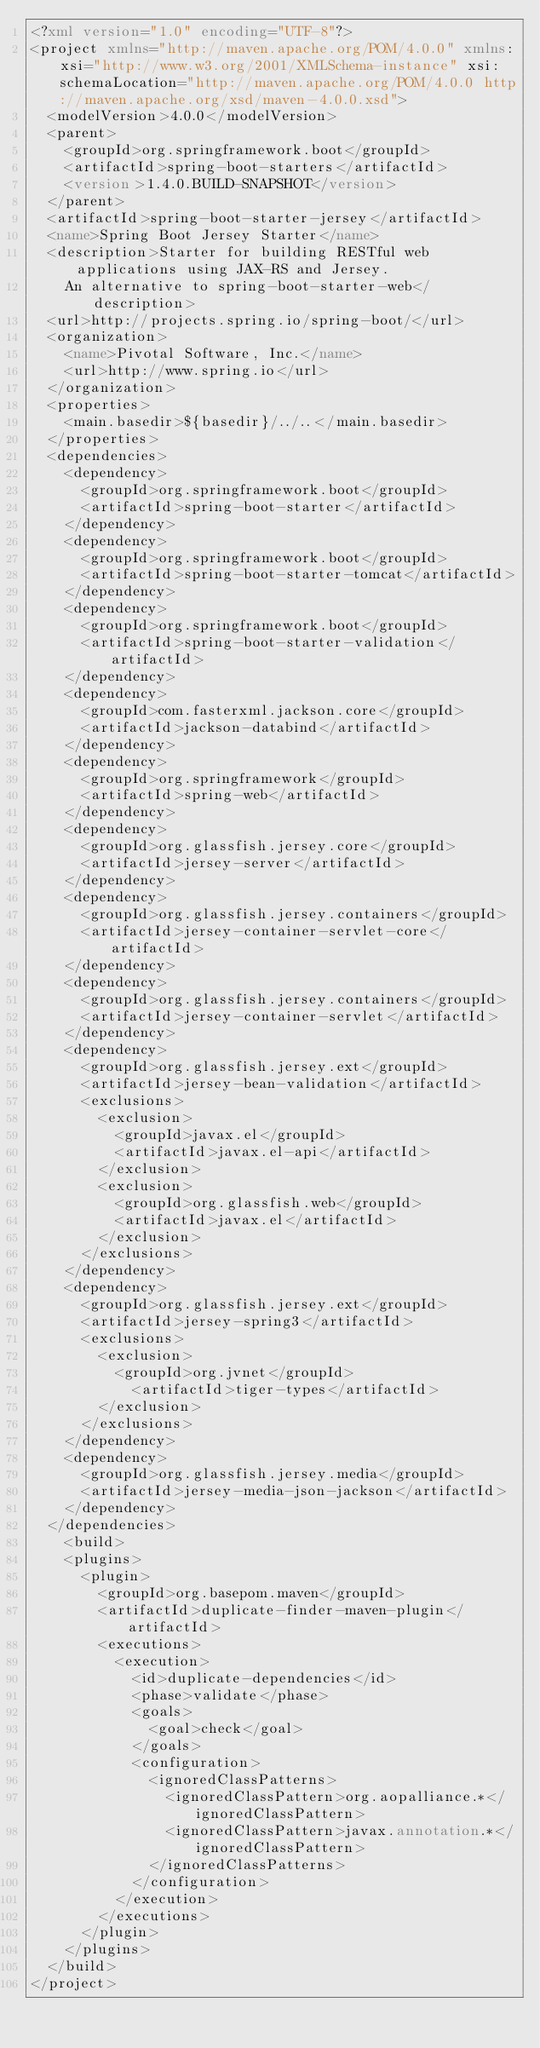<code> <loc_0><loc_0><loc_500><loc_500><_XML_><?xml version="1.0" encoding="UTF-8"?>
<project xmlns="http://maven.apache.org/POM/4.0.0" xmlns:xsi="http://www.w3.org/2001/XMLSchema-instance" xsi:schemaLocation="http://maven.apache.org/POM/4.0.0 http://maven.apache.org/xsd/maven-4.0.0.xsd">
	<modelVersion>4.0.0</modelVersion>
	<parent>
		<groupId>org.springframework.boot</groupId>
		<artifactId>spring-boot-starters</artifactId>
		<version>1.4.0.BUILD-SNAPSHOT</version>
	</parent>
	<artifactId>spring-boot-starter-jersey</artifactId>
	<name>Spring Boot Jersey Starter</name>
	<description>Starter for building RESTful web applications using JAX-RS and Jersey.
		An alternative to spring-boot-starter-web</description>
	<url>http://projects.spring.io/spring-boot/</url>
	<organization>
		<name>Pivotal Software, Inc.</name>
		<url>http://www.spring.io</url>
	</organization>
	<properties>
		<main.basedir>${basedir}/../..</main.basedir>
	</properties>
	<dependencies>
		<dependency>
			<groupId>org.springframework.boot</groupId>
			<artifactId>spring-boot-starter</artifactId>
		</dependency>
		<dependency>
			<groupId>org.springframework.boot</groupId>
			<artifactId>spring-boot-starter-tomcat</artifactId>
		</dependency>
		<dependency>
			<groupId>org.springframework.boot</groupId>
			<artifactId>spring-boot-starter-validation</artifactId>
		</dependency>
		<dependency>
			<groupId>com.fasterxml.jackson.core</groupId>
			<artifactId>jackson-databind</artifactId>
		</dependency>
		<dependency>
			<groupId>org.springframework</groupId>
			<artifactId>spring-web</artifactId>
		</dependency>
		<dependency>
			<groupId>org.glassfish.jersey.core</groupId>
			<artifactId>jersey-server</artifactId>
		</dependency>
		<dependency>
			<groupId>org.glassfish.jersey.containers</groupId>
			<artifactId>jersey-container-servlet-core</artifactId>
		</dependency>
		<dependency>
			<groupId>org.glassfish.jersey.containers</groupId>
			<artifactId>jersey-container-servlet</artifactId>
		</dependency>
		<dependency>
			<groupId>org.glassfish.jersey.ext</groupId>
			<artifactId>jersey-bean-validation</artifactId>
			<exclusions>
				<exclusion>
					<groupId>javax.el</groupId>
					<artifactId>javax.el-api</artifactId>
				</exclusion>
				<exclusion>
					<groupId>org.glassfish.web</groupId>
					<artifactId>javax.el</artifactId>
				</exclusion>
			</exclusions>
		</dependency>
		<dependency>
			<groupId>org.glassfish.jersey.ext</groupId>
			<artifactId>jersey-spring3</artifactId>
			<exclusions>
				<exclusion>
					<groupId>org.jvnet</groupId>
  					<artifactId>tiger-types</artifactId>
				</exclusion>
			</exclusions>
		</dependency>
		<dependency>
			<groupId>org.glassfish.jersey.media</groupId>
			<artifactId>jersey-media-json-jackson</artifactId>
		</dependency>
	</dependencies>
		<build>
		<plugins>
			<plugin>
				<groupId>org.basepom.maven</groupId>
				<artifactId>duplicate-finder-maven-plugin</artifactId>
				<executions>
					<execution>
						<id>duplicate-dependencies</id>
						<phase>validate</phase>
						<goals>
							<goal>check</goal>
						</goals>
						<configuration>
							<ignoredClassPatterns>
								<ignoredClassPattern>org.aopalliance.*</ignoredClassPattern>
								<ignoredClassPattern>javax.annotation.*</ignoredClassPattern>
							</ignoredClassPatterns>
						</configuration>
					</execution>
				</executions>
			</plugin>
		</plugins>
	</build>
</project>
</code> 